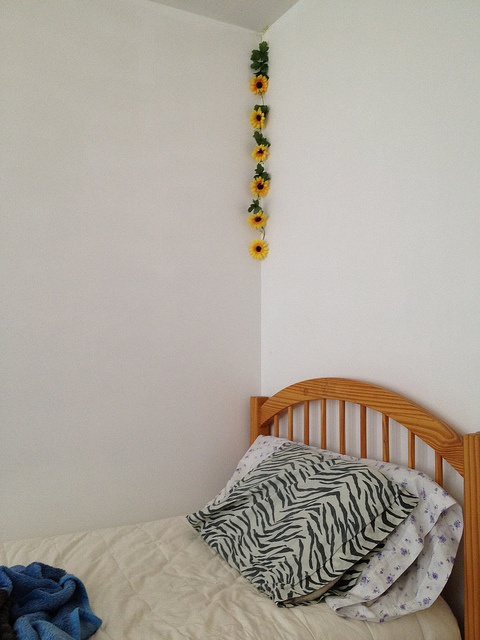Describe the objects in this image and their specific colors. I can see a bed in darkgray, brown, gray, and black tones in this image. 